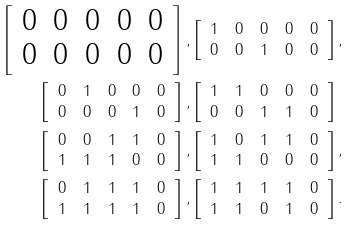<formula> <loc_0><loc_0><loc_500><loc_500>\left [ \begin{array} { c c c c c } 0 & 0 & 0 & 0 & 0 \\ 0 & 0 & 0 & 0 & 0 \end{array} \right ] , & \left [ \begin{array} { c c c c c } 1 & 0 & 0 & 0 & 0 \\ 0 & 0 & 1 & 0 & 0 \end{array} \right ] , \\ \left [ \begin{array} { c c c c c } 0 & 1 & 0 & 0 & 0 \\ 0 & 0 & 0 & 1 & 0 \end{array} \right ] , & \left [ \begin{array} { c c c c c } 1 & 1 & 0 & 0 & 0 \\ 0 & 0 & 1 & 1 & 0 \end{array} \right ] \\ \left [ \begin{array} { c c c c c } 0 & 0 & 1 & 1 & 0 \\ 1 & 1 & 1 & 0 & 0 \end{array} \right ] , & \left [ \begin{array} { c c c c c } 1 & 0 & 1 & 1 & 0 \\ 1 & 1 & 0 & 0 & 0 \end{array} \right ] , \\ \left [ \begin{array} { c c c c c } 0 & 1 & 1 & 1 & 0 \\ 1 & 1 & 1 & 1 & 0 \end{array} \right ] , & \left [ \begin{array} { c c c c c } 1 & 1 & 1 & 1 & 0 \\ 1 & 1 & 0 & 1 & 0 \end{array} \right ] .</formula> 